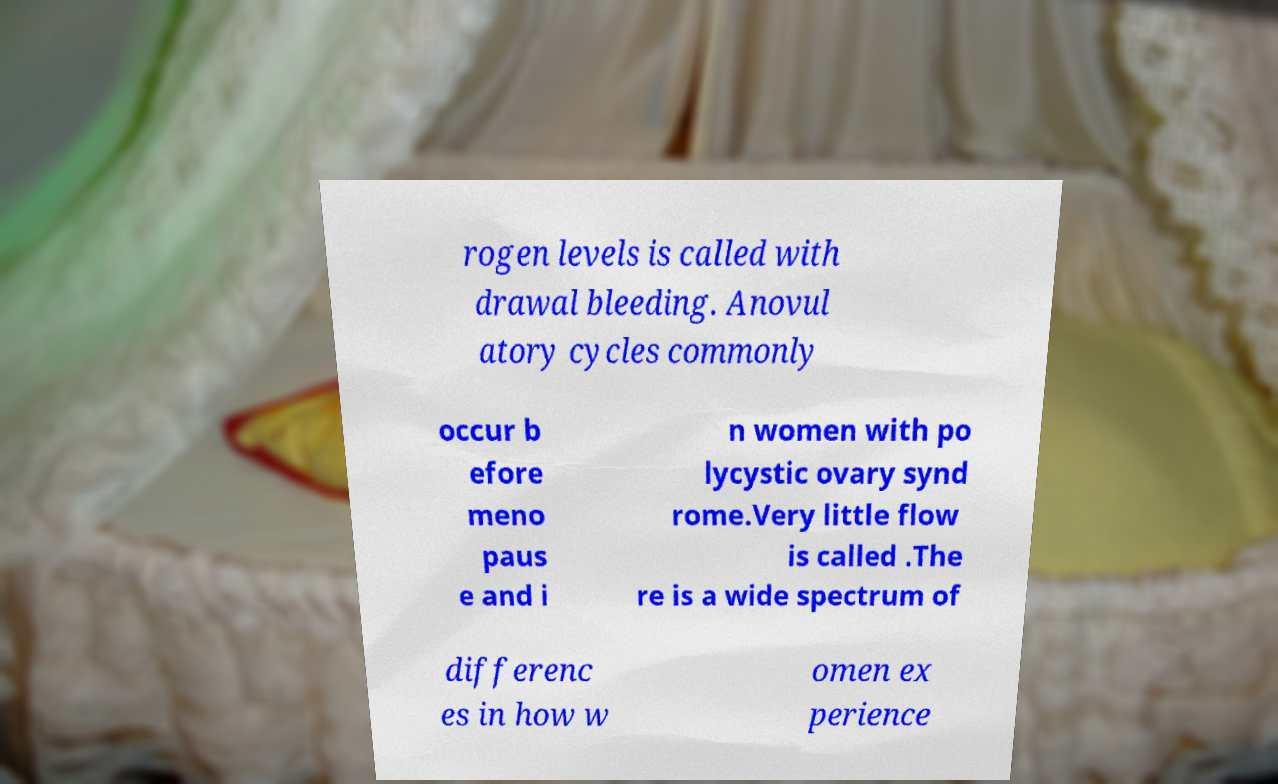I need the written content from this picture converted into text. Can you do that? rogen levels is called with drawal bleeding. Anovul atory cycles commonly occur b efore meno paus e and i n women with po lycystic ovary synd rome.Very little flow is called .The re is a wide spectrum of differenc es in how w omen ex perience 